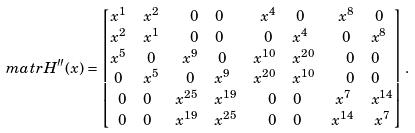Convert formula to latex. <formula><loc_0><loc_0><loc_500><loc_500>\ m a t r { H } ^ { \prime \prime } ( x ) & = \begin{bmatrix} \begin{matrix} x ^ { 1 } & x ^ { 2 } \\ x ^ { 2 } & x ^ { 1 } \end{matrix} & \begin{matrix} 0 & 0 \\ 0 & 0 \end{matrix} & \begin{matrix} x ^ { 4 } & 0 \\ 0 & x ^ { 4 } \end{matrix} & \begin{matrix} x ^ { 8 } & 0 \\ 0 & x ^ { 8 } \end{matrix} \\ \begin{matrix} x ^ { 5 } & 0 \\ 0 & x ^ { 5 } \end{matrix} & \begin{matrix} x ^ { 9 } & 0 \\ 0 & x ^ { 9 } \end{matrix} & \begin{matrix} x ^ { 1 0 } & x ^ { 2 0 } \\ x ^ { 2 0 } & x ^ { 1 0 } \end{matrix} & \begin{matrix} 0 & 0 \\ 0 & 0 \end{matrix} \\ \begin{matrix} 0 & 0 \\ 0 & 0 \end{matrix} & \begin{matrix} x ^ { 2 5 } & x ^ { 1 9 } \\ x ^ { 1 9 } & x ^ { 2 5 } \end{matrix} & \begin{matrix} 0 & 0 \\ 0 & 0 \end{matrix} & \begin{matrix} x ^ { 7 } & x ^ { 1 4 } \\ x ^ { 1 4 } & x ^ { 7 } \end{matrix} \end{bmatrix} .</formula> 